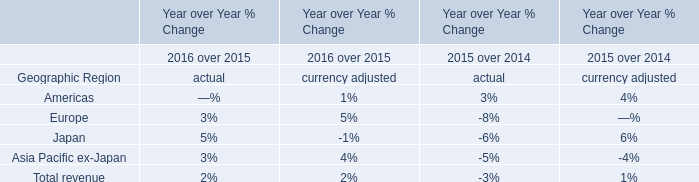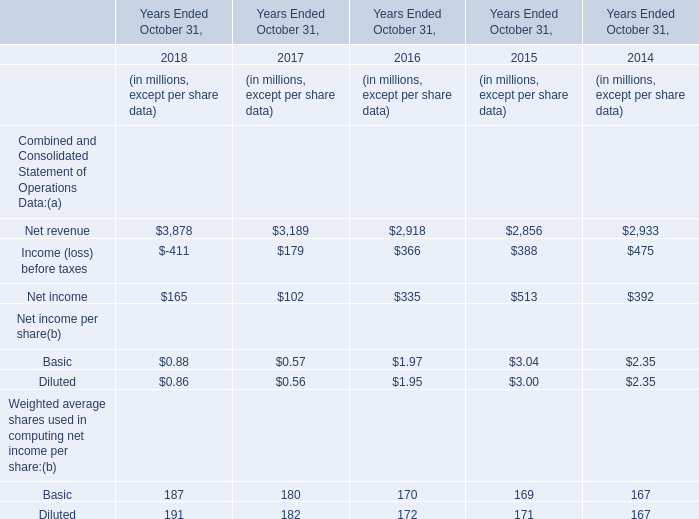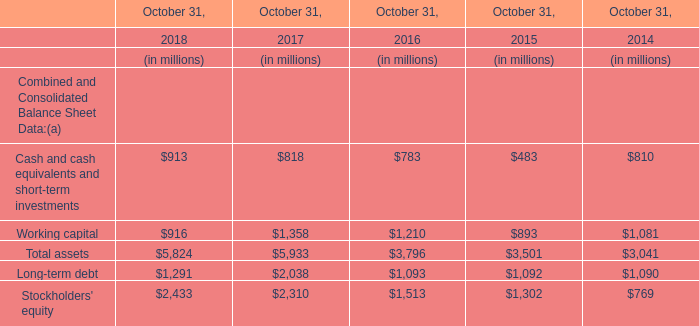How many kinds of elements are greater than 300 in 2016? 
Answer: 3. 